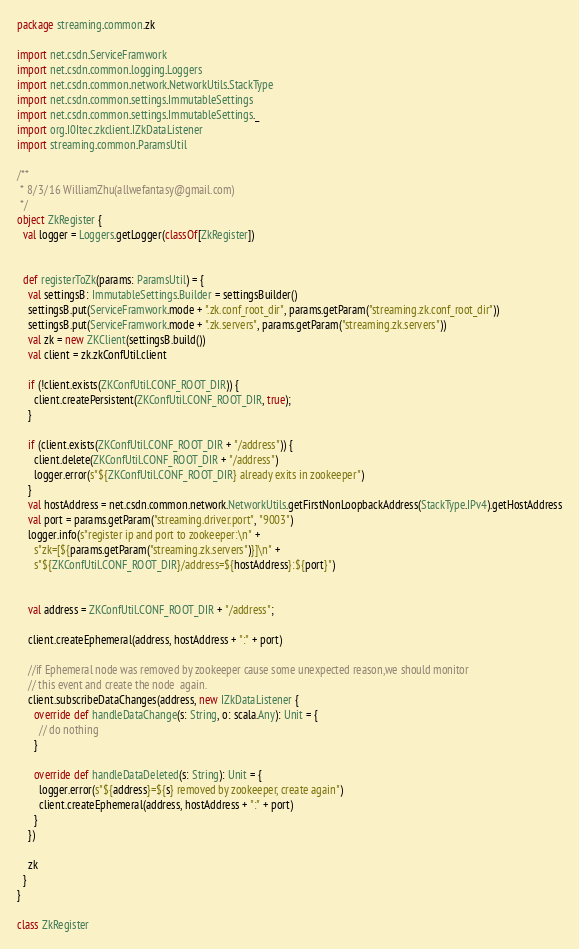<code> <loc_0><loc_0><loc_500><loc_500><_Scala_>package streaming.common.zk

import net.csdn.ServiceFramwork
import net.csdn.common.logging.Loggers
import net.csdn.common.network.NetworkUtils.StackType
import net.csdn.common.settings.ImmutableSettings
import net.csdn.common.settings.ImmutableSettings._
import org.I0Itec.zkclient.IZkDataListener
import streaming.common.ParamsUtil

/**
 * 8/3/16 WilliamZhu(allwefantasy@gmail.com)
 */
object ZkRegister {
  val logger = Loggers.getLogger(classOf[ZkRegister])


  def registerToZk(params: ParamsUtil) = {
    val settingsB: ImmutableSettings.Builder = settingsBuilder()
    settingsB.put(ServiceFramwork.mode + ".zk.conf_root_dir", params.getParam("streaming.zk.conf_root_dir"))
    settingsB.put(ServiceFramwork.mode + ".zk.servers", params.getParam("streaming.zk.servers"))
    val zk = new ZKClient(settingsB.build())
    val client = zk.zkConfUtil.client

    if (!client.exists(ZKConfUtil.CONF_ROOT_DIR)) {
      client.createPersistent(ZKConfUtil.CONF_ROOT_DIR, true);
    }

    if (client.exists(ZKConfUtil.CONF_ROOT_DIR + "/address")) {
      client.delete(ZKConfUtil.CONF_ROOT_DIR + "/address")
      logger.error(s"${ZKConfUtil.CONF_ROOT_DIR} already exits in zookeeper")
    }
    val hostAddress = net.csdn.common.network.NetworkUtils.getFirstNonLoopbackAddress(StackType.IPv4).getHostAddress
    val port = params.getParam("streaming.driver.port", "9003")
    logger.info(s"register ip and port to zookeeper:\n" +
      s"zk=[${params.getParam("streaming.zk.servers")}]\n" +
      s"${ZKConfUtil.CONF_ROOT_DIR}/address=${hostAddress}:${port}")


    val address = ZKConfUtil.CONF_ROOT_DIR + "/address";

    client.createEphemeral(address, hostAddress + ":" + port)

    //if Ephemeral node was removed by zookeeper cause some unexpected reason,we should monitor
    // this event and create the node  again.
    client.subscribeDataChanges(address, new IZkDataListener {
      override def handleDataChange(s: String, o: scala.Any): Unit = {
        // do nothing
      }

      override def handleDataDeleted(s: String): Unit = {
        logger.error(s"${address}=${s} removed by zookeeper, create again")
        client.createEphemeral(address, hostAddress + ":" + port)
      }
    })

    zk
  }
}

class ZkRegister
</code> 